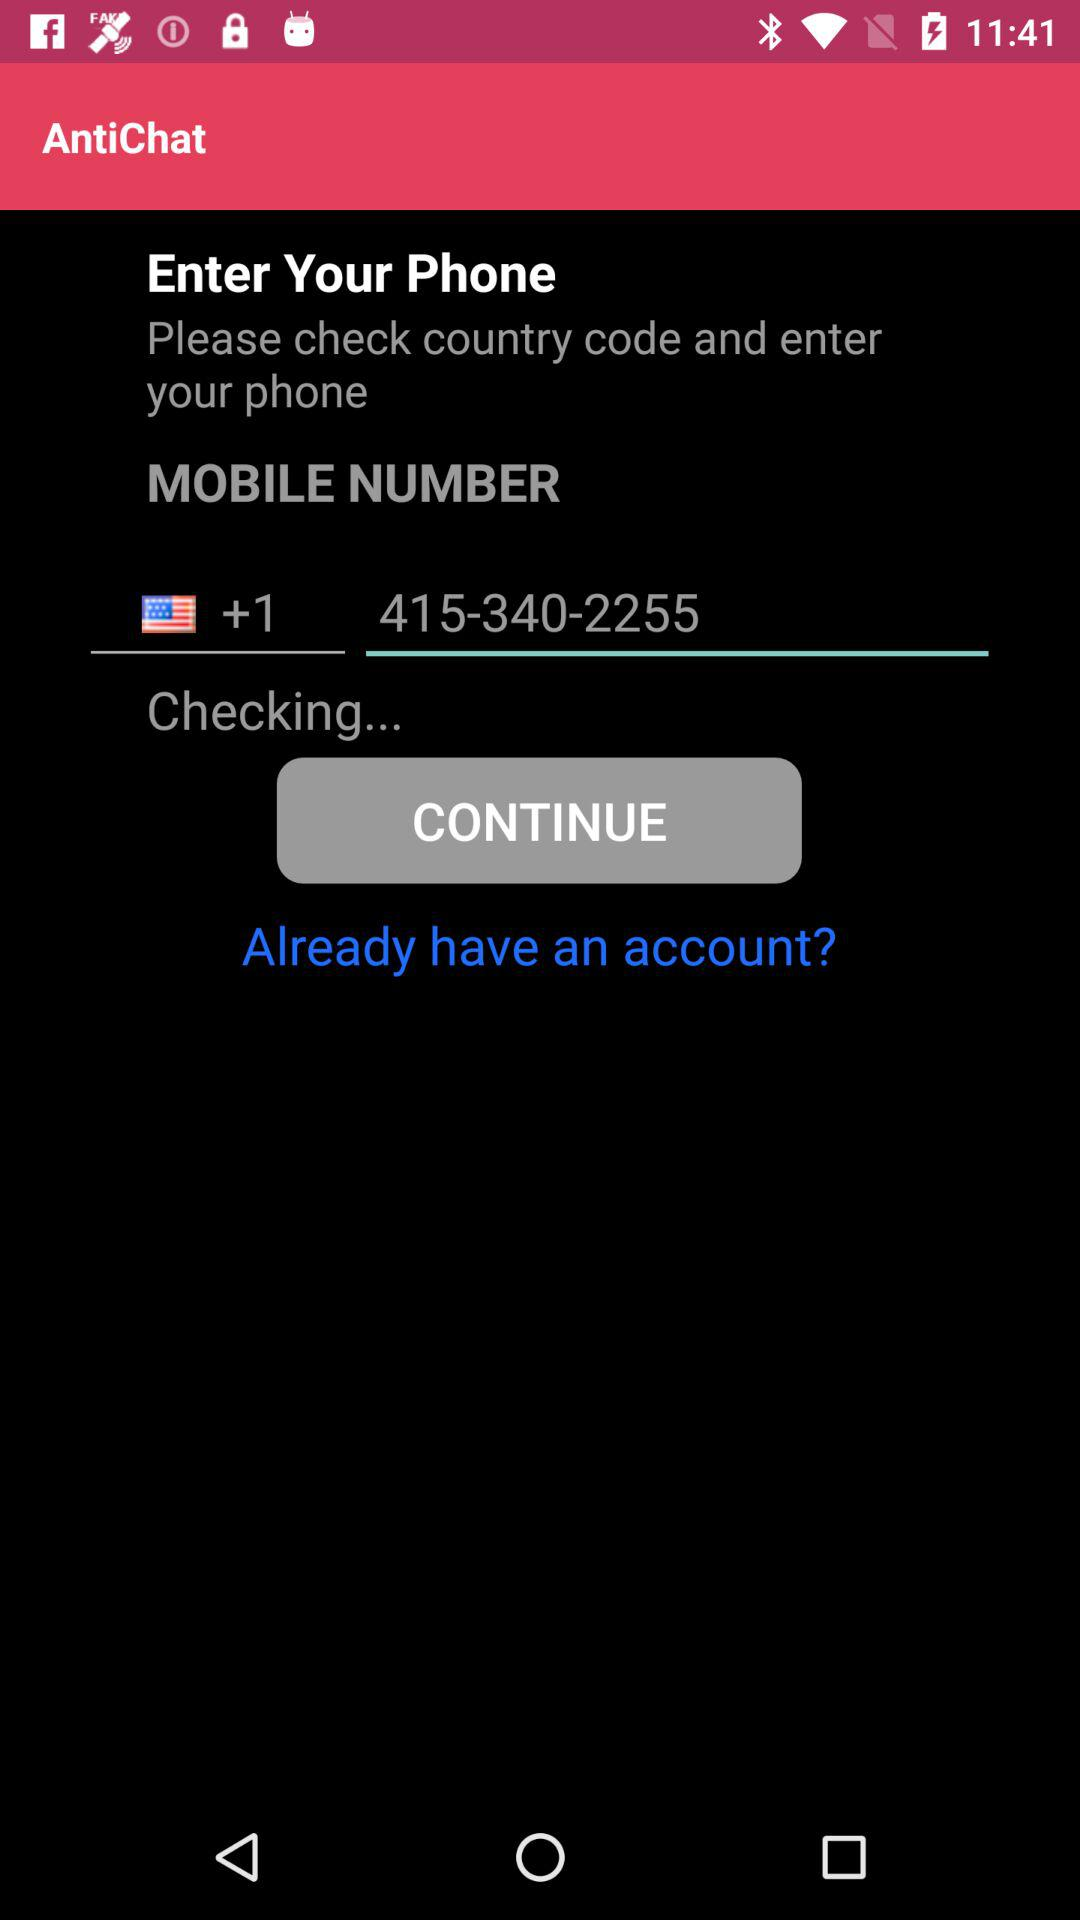What is the application name? The application name is "AntiChat". 